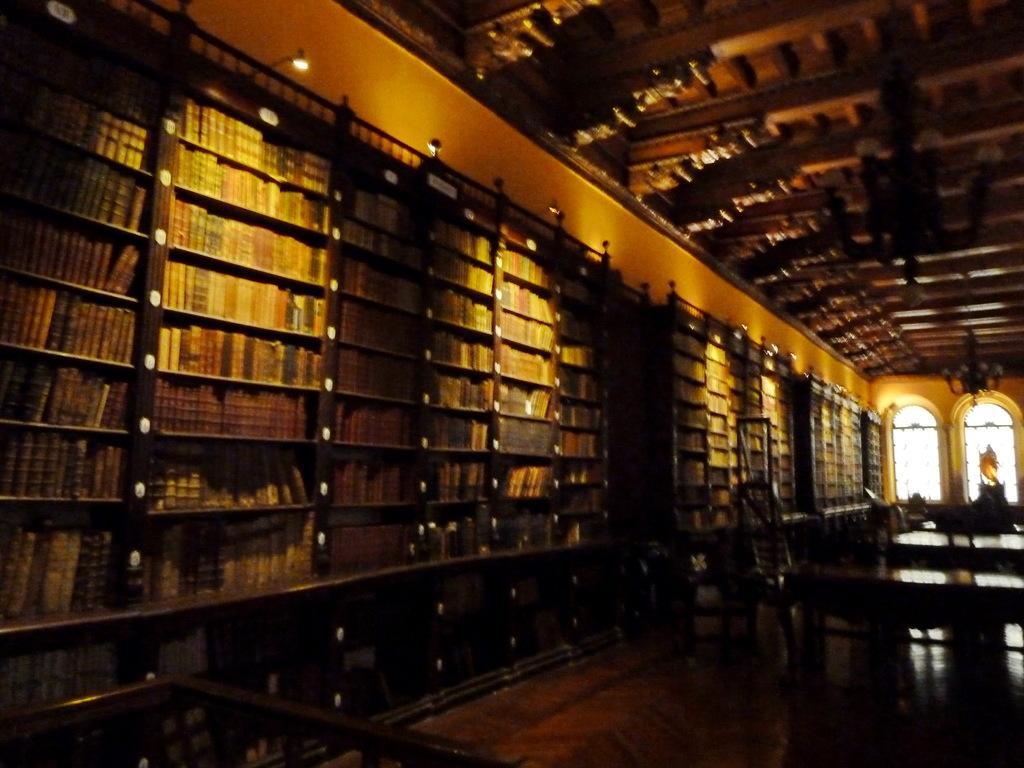Describe this image in one or two sentences. In this picture, we see the racks in which many books are placed. On the right side, we see the chairs and the table. In the background, we see the windows and a wall. At the top, we see the roof of the building. At the bottom, we see the railing and the wooden floor. This picture might be clicked in the library. 